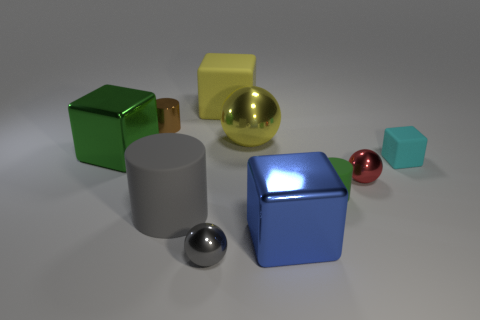Subtract all big shiny spheres. How many spheres are left? 2 Subtract 2 spheres. How many spheres are left? 1 Subtract all yellow spheres. How many spheres are left? 2 Subtract all spheres. How many objects are left? 7 Add 1 tiny gray shiny things. How many tiny gray shiny things are left? 2 Add 4 gray things. How many gray things exist? 6 Subtract 0 purple cubes. How many objects are left? 10 Subtract all cyan cubes. Subtract all red balls. How many cubes are left? 3 Subtract all large yellow metal spheres. Subtract all cyan matte objects. How many objects are left? 8 